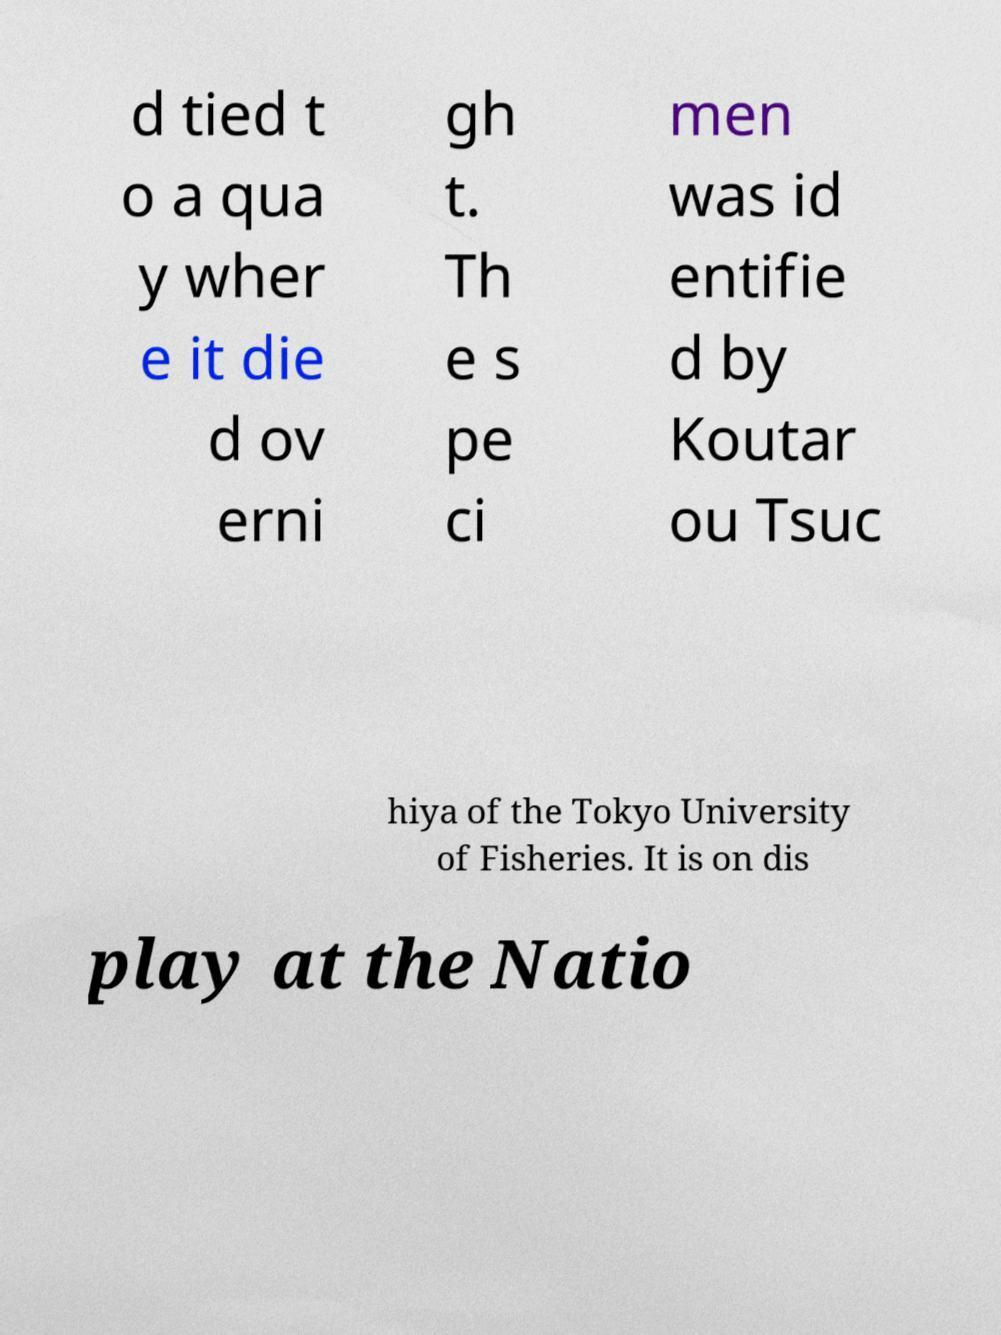Can you read and provide the text displayed in the image?This photo seems to have some interesting text. Can you extract and type it out for me? d tied t o a qua y wher e it die d ov erni gh t. Th e s pe ci men was id entifie d by Koutar ou Tsuc hiya of the Tokyo University of Fisheries. It is on dis play at the Natio 